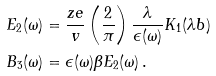Convert formula to latex. <formula><loc_0><loc_0><loc_500><loc_500>E _ { 2 } ( \omega ) & = \frac { z e } { v } \left ( \frac { 2 } { \pi } \right ) \frac { \lambda } { \epsilon ( \omega ) } K _ { 1 } ( \lambda b ) \\ B _ { 3 } ( \omega ) & = \epsilon ( \omega ) \beta E _ { 2 } ( \omega ) \, .</formula> 